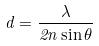<formula> <loc_0><loc_0><loc_500><loc_500>d = \frac { \lambda } { 2 n \sin \theta }</formula> 